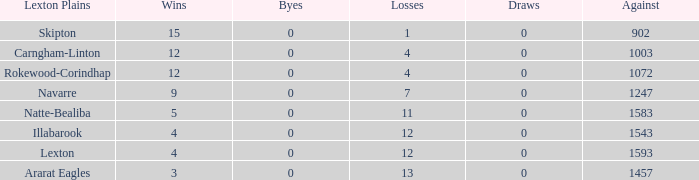Can you parse all the data within this table? {'header': ['Lexton Plains', 'Wins', 'Byes', 'Losses', 'Draws', 'Against'], 'rows': [['Skipton', '15', '0', '1', '0', '902'], ['Carngham-Linton', '12', '0', '4', '0', '1003'], ['Rokewood-Corindhap', '12', '0', '4', '0', '1072'], ['Navarre', '9', '0', '7', '0', '1247'], ['Natte-Bealiba', '5', '0', '11', '0', '1583'], ['Illabarook', '4', '0', '12', '0', '1543'], ['Lexton', '4', '0', '12', '0', '1593'], ['Ararat Eagles', '3', '0', '13', '0', '1457']]} What is the greatest number of victories with no byes? None. 